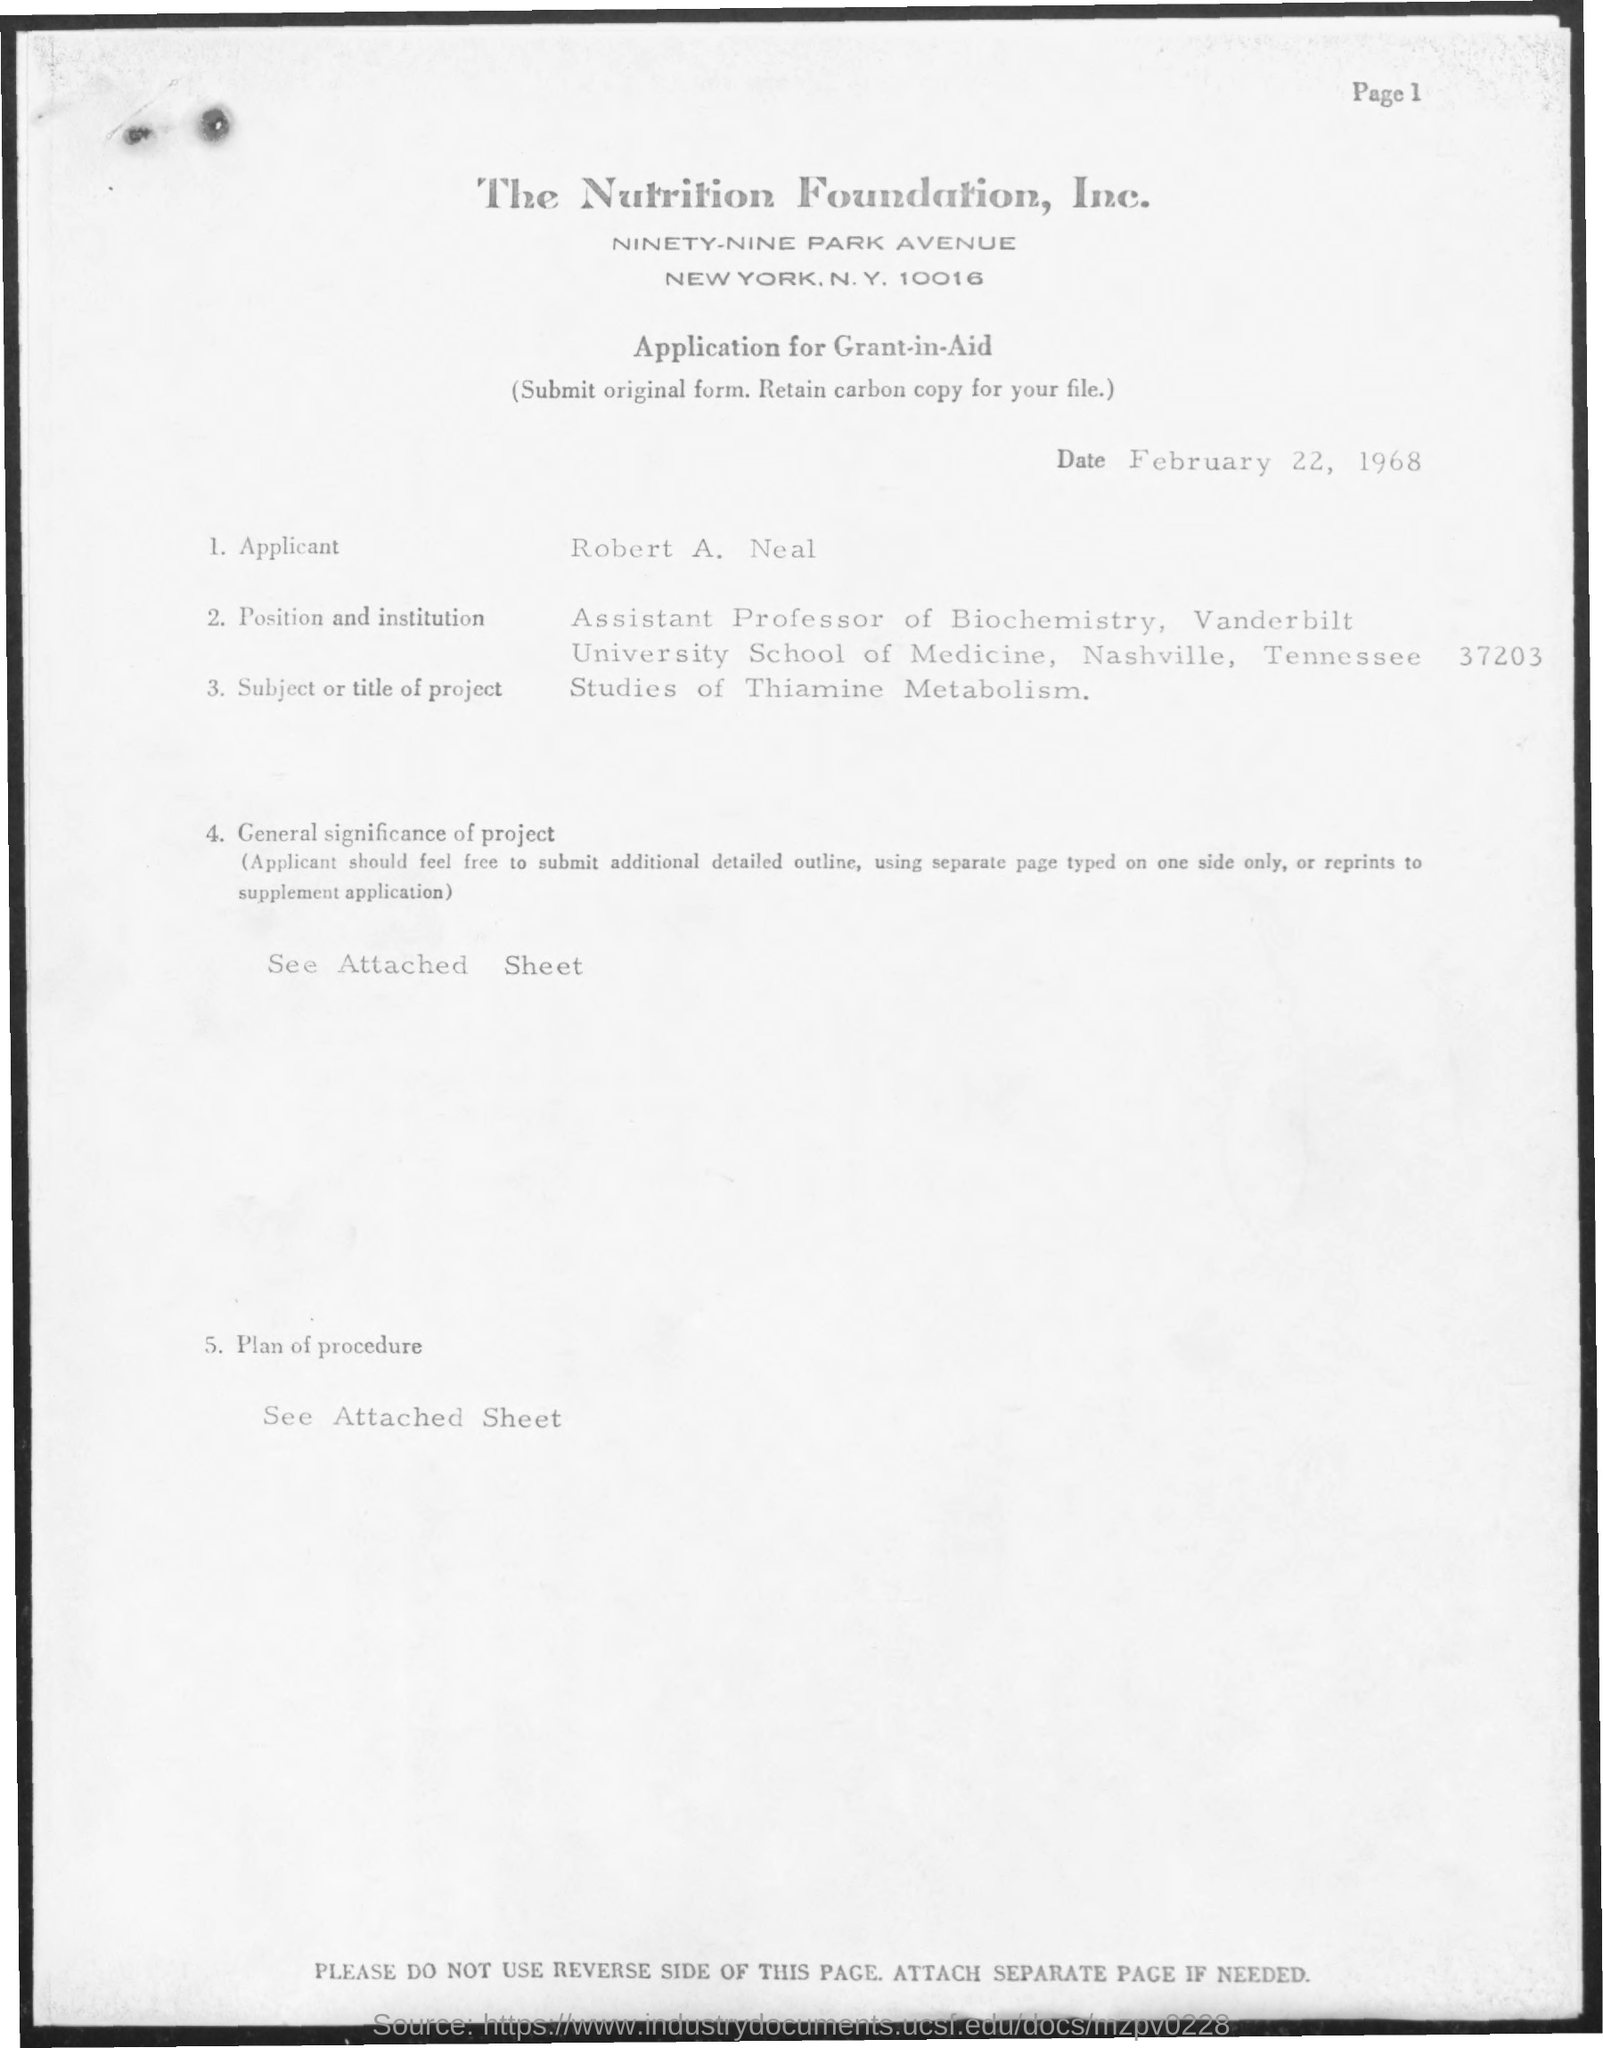What for the application for?
Keep it short and to the point. Grant-in-Aid. What is the name of foundation?
Give a very brief answer. The Nutrition Foundation. What is the date of application?
Provide a succinct answer. February 22, 1968. What is the position?
Your answer should be very brief. Assistant Professor of Biochemistry. What is the title of the project?
Keep it short and to the point. Studies of Thiamine Metabolism. 